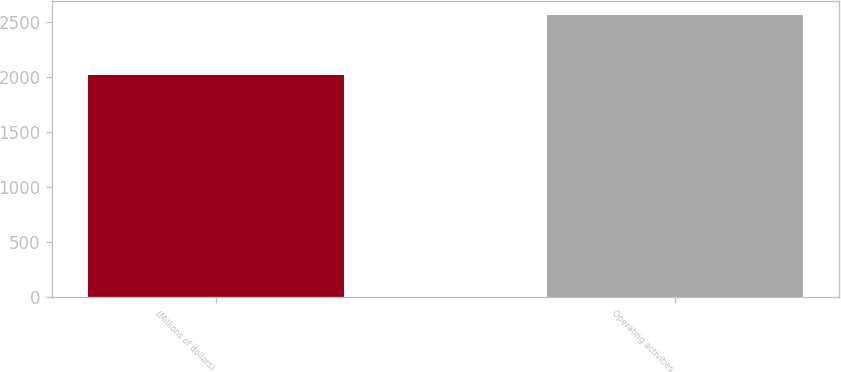<chart> <loc_0><loc_0><loc_500><loc_500><bar_chart><fcel>(Millions of dollars)<fcel>Operating activities<nl><fcel>2016<fcel>2559<nl></chart> 